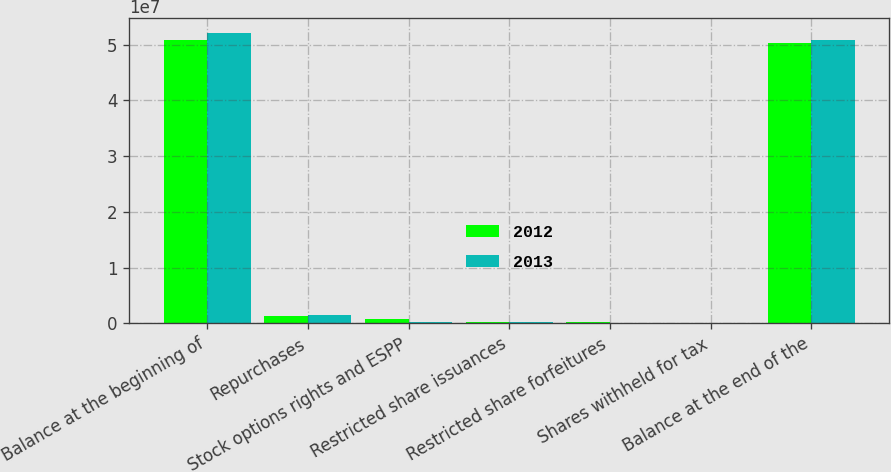<chart> <loc_0><loc_0><loc_500><loc_500><stacked_bar_chart><ecel><fcel>Balance at the beginning of<fcel>Repurchases<fcel>Stock options rights and ESPP<fcel>Restricted share issuances<fcel>Restricted share forfeitures<fcel>Shares withheld for tax<fcel>Balance at the end of the<nl><fcel>2012<fcel>5.09083e+07<fcel>1.35686e+06<fcel>739148<fcel>241851<fcel>165610<fcel>17249<fcel>5.03495e+07<nl><fcel>2013<fcel>5.20952e+07<fcel>1.47386e+06<fcel>246625<fcel>242238<fcel>130119<fcel>71780<fcel>5.09083e+07<nl></chart> 